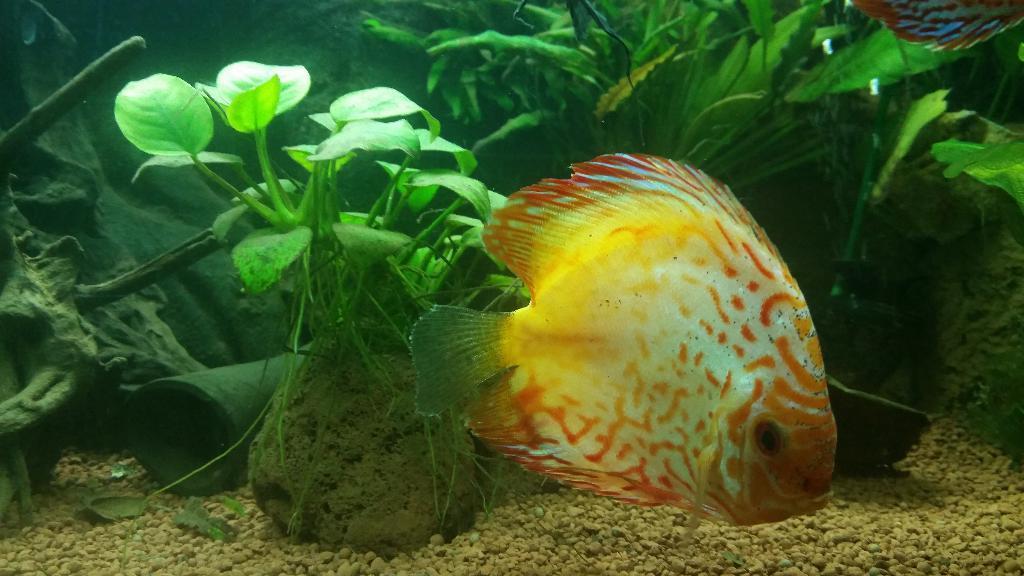Describe this image in one or two sentences. In this picture we can see there are two fishes in the water and behind the fish there are plants, stones and other items. 